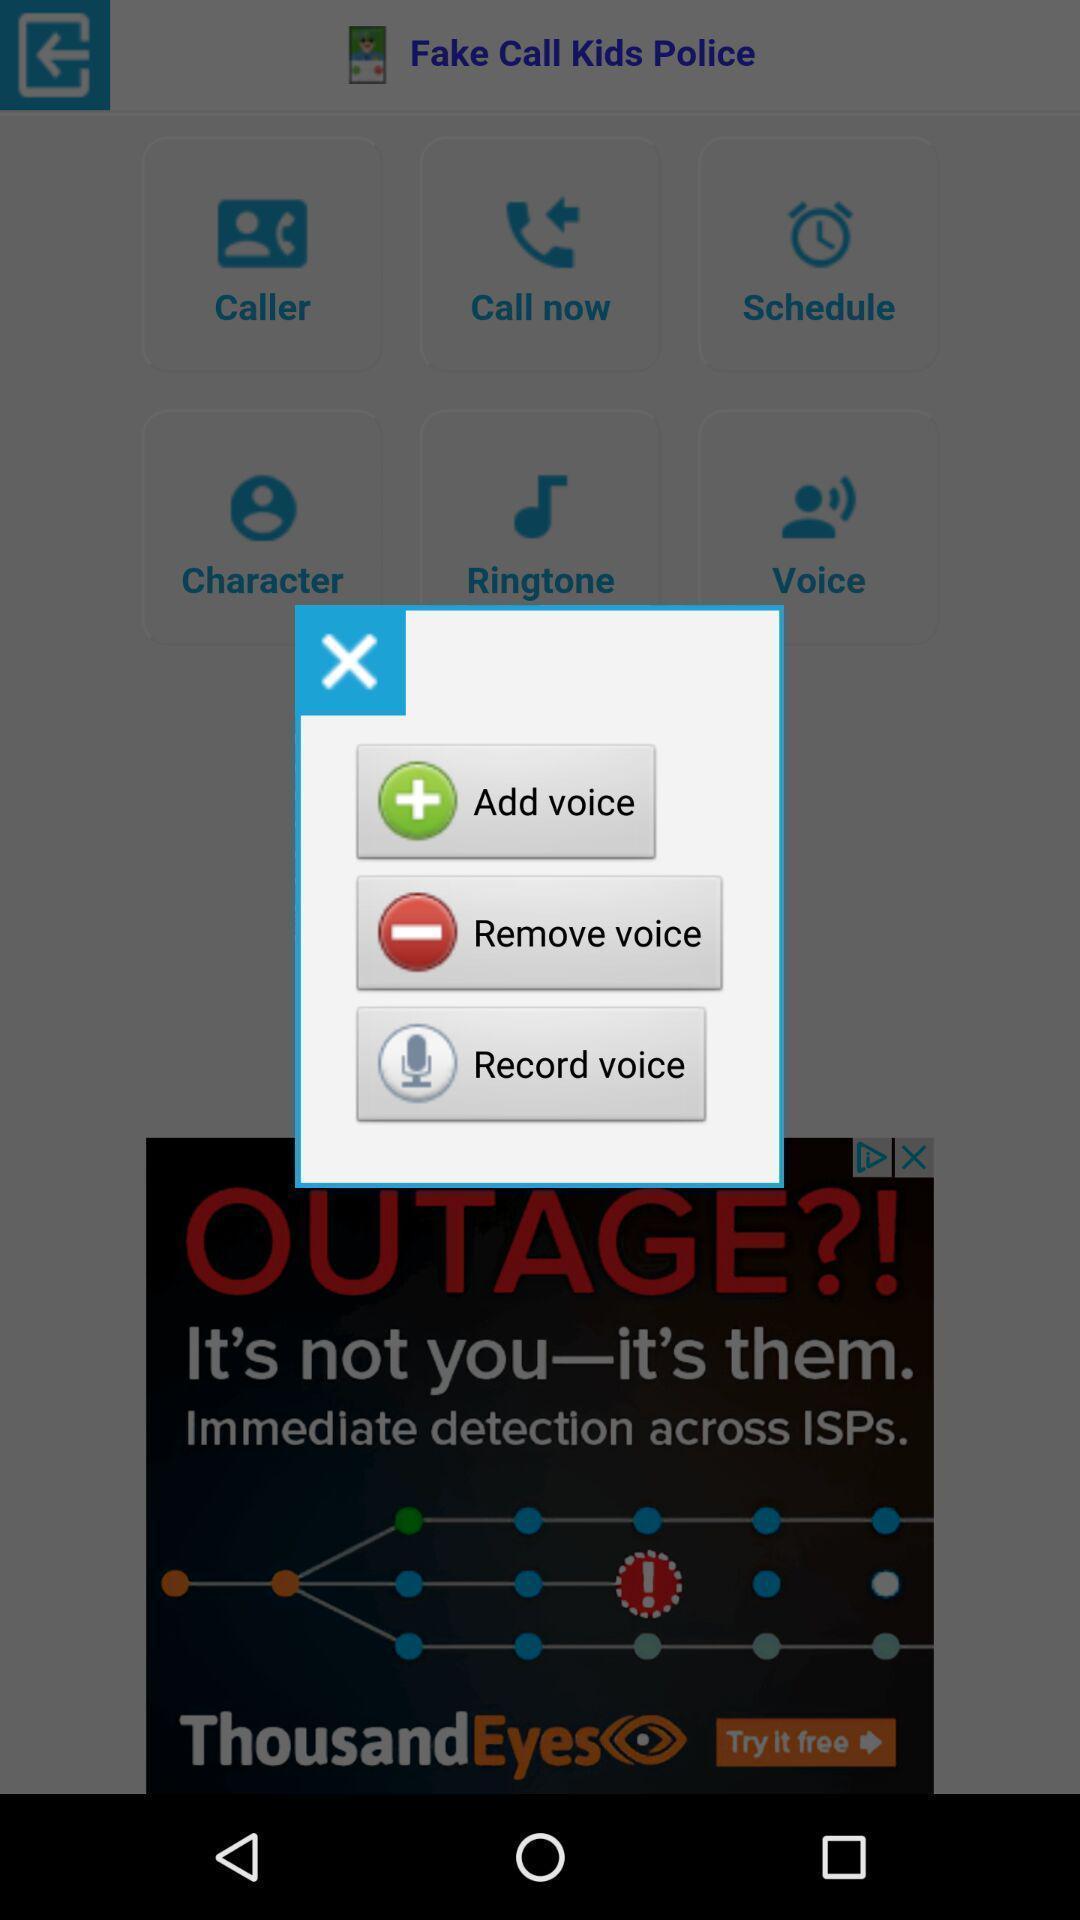Please provide a description for this image. Pop-up showing multiple voice options. 